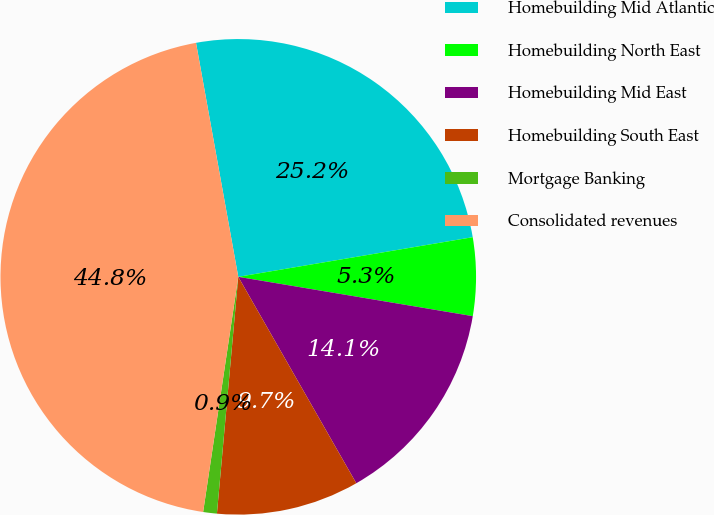<chart> <loc_0><loc_0><loc_500><loc_500><pie_chart><fcel>Homebuilding Mid Atlantic<fcel>Homebuilding North East<fcel>Homebuilding Mid East<fcel>Homebuilding South East<fcel>Mortgage Banking<fcel>Consolidated revenues<nl><fcel>25.18%<fcel>5.31%<fcel>14.09%<fcel>9.7%<fcel>0.93%<fcel>44.8%<nl></chart> 